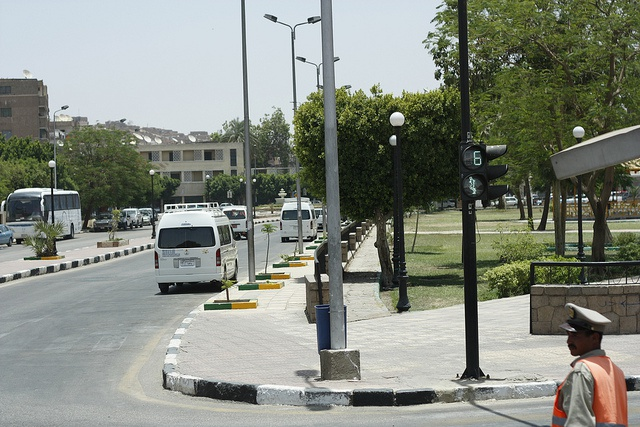Describe the objects in this image and their specific colors. I can see car in lightgray, darkgray, black, and gray tones, people in lightgray, gray, black, darkgray, and brown tones, bus in lightgray, black, darkgray, and purple tones, traffic light in lightgray, black, gray, and darkgray tones, and car in lightgray, darkgray, black, and gray tones in this image. 